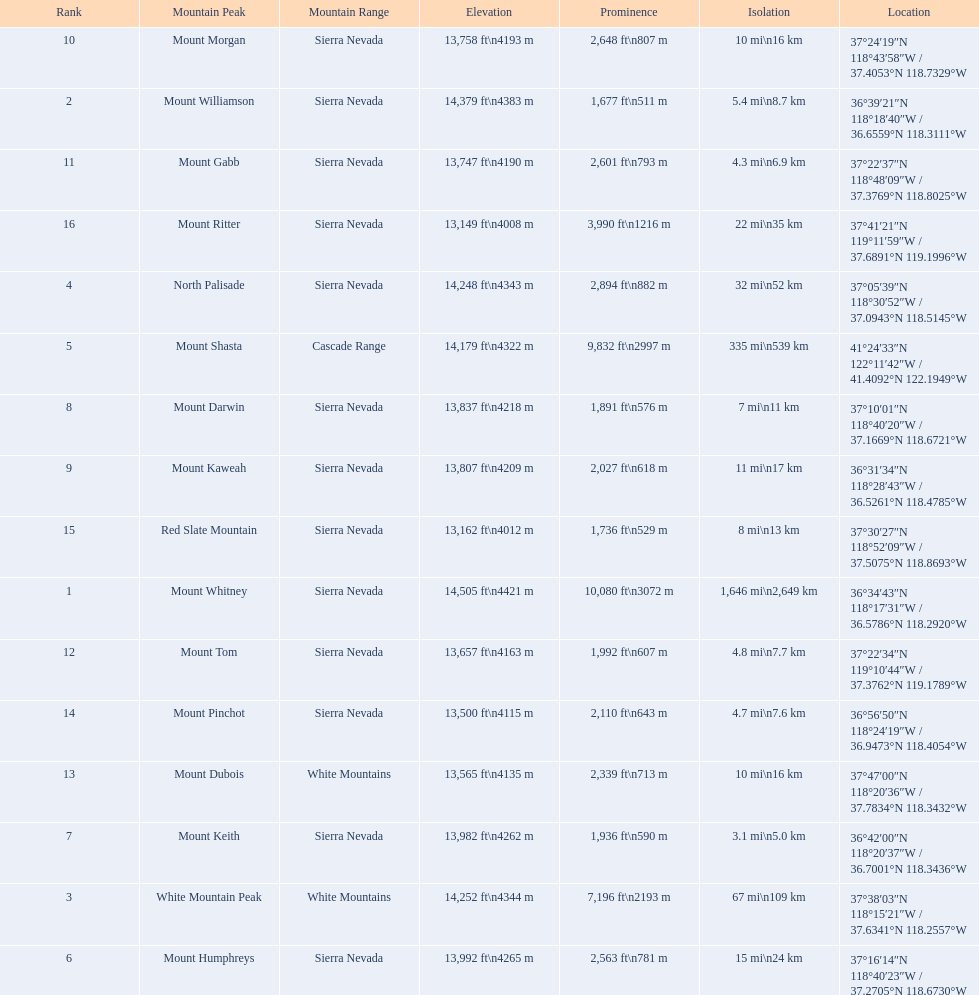What are the mountain peaks? Mount Whitney, Mount Williamson, White Mountain Peak, North Palisade, Mount Shasta, Mount Humphreys, Mount Keith, Mount Darwin, Mount Kaweah, Mount Morgan, Mount Gabb, Mount Tom, Mount Dubois, Mount Pinchot, Red Slate Mountain, Mount Ritter. Of these, which one has a prominence more than 10,000 ft? Mount Whitney. 